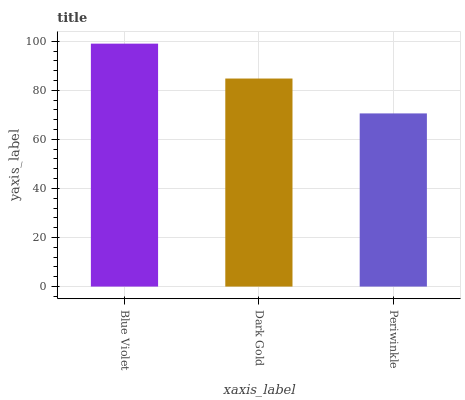Is Dark Gold the minimum?
Answer yes or no. No. Is Dark Gold the maximum?
Answer yes or no. No. Is Blue Violet greater than Dark Gold?
Answer yes or no. Yes. Is Dark Gold less than Blue Violet?
Answer yes or no. Yes. Is Dark Gold greater than Blue Violet?
Answer yes or no. No. Is Blue Violet less than Dark Gold?
Answer yes or no. No. Is Dark Gold the high median?
Answer yes or no. Yes. Is Dark Gold the low median?
Answer yes or no. Yes. Is Blue Violet the high median?
Answer yes or no. No. Is Periwinkle the low median?
Answer yes or no. No. 